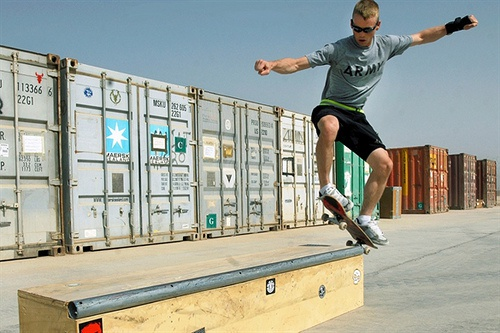Describe the objects in this image and their specific colors. I can see people in gray, black, maroon, and darkgray tones and skateboard in gray, black, and maroon tones in this image. 